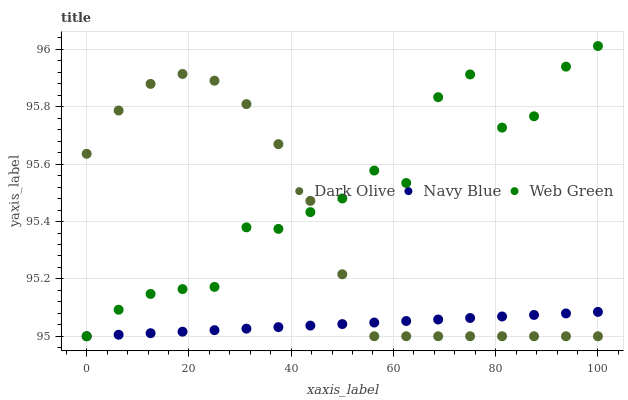Does Navy Blue have the minimum area under the curve?
Answer yes or no. Yes. Does Web Green have the maximum area under the curve?
Answer yes or no. Yes. Does Dark Olive have the minimum area under the curve?
Answer yes or no. No. Does Dark Olive have the maximum area under the curve?
Answer yes or no. No. Is Navy Blue the smoothest?
Answer yes or no. Yes. Is Web Green the roughest?
Answer yes or no. Yes. Is Dark Olive the smoothest?
Answer yes or no. No. Is Dark Olive the roughest?
Answer yes or no. No. Does Navy Blue have the lowest value?
Answer yes or no. Yes. Does Web Green have the highest value?
Answer yes or no. Yes. Does Dark Olive have the highest value?
Answer yes or no. No. Does Dark Olive intersect Web Green?
Answer yes or no. Yes. Is Dark Olive less than Web Green?
Answer yes or no. No. Is Dark Olive greater than Web Green?
Answer yes or no. No. 